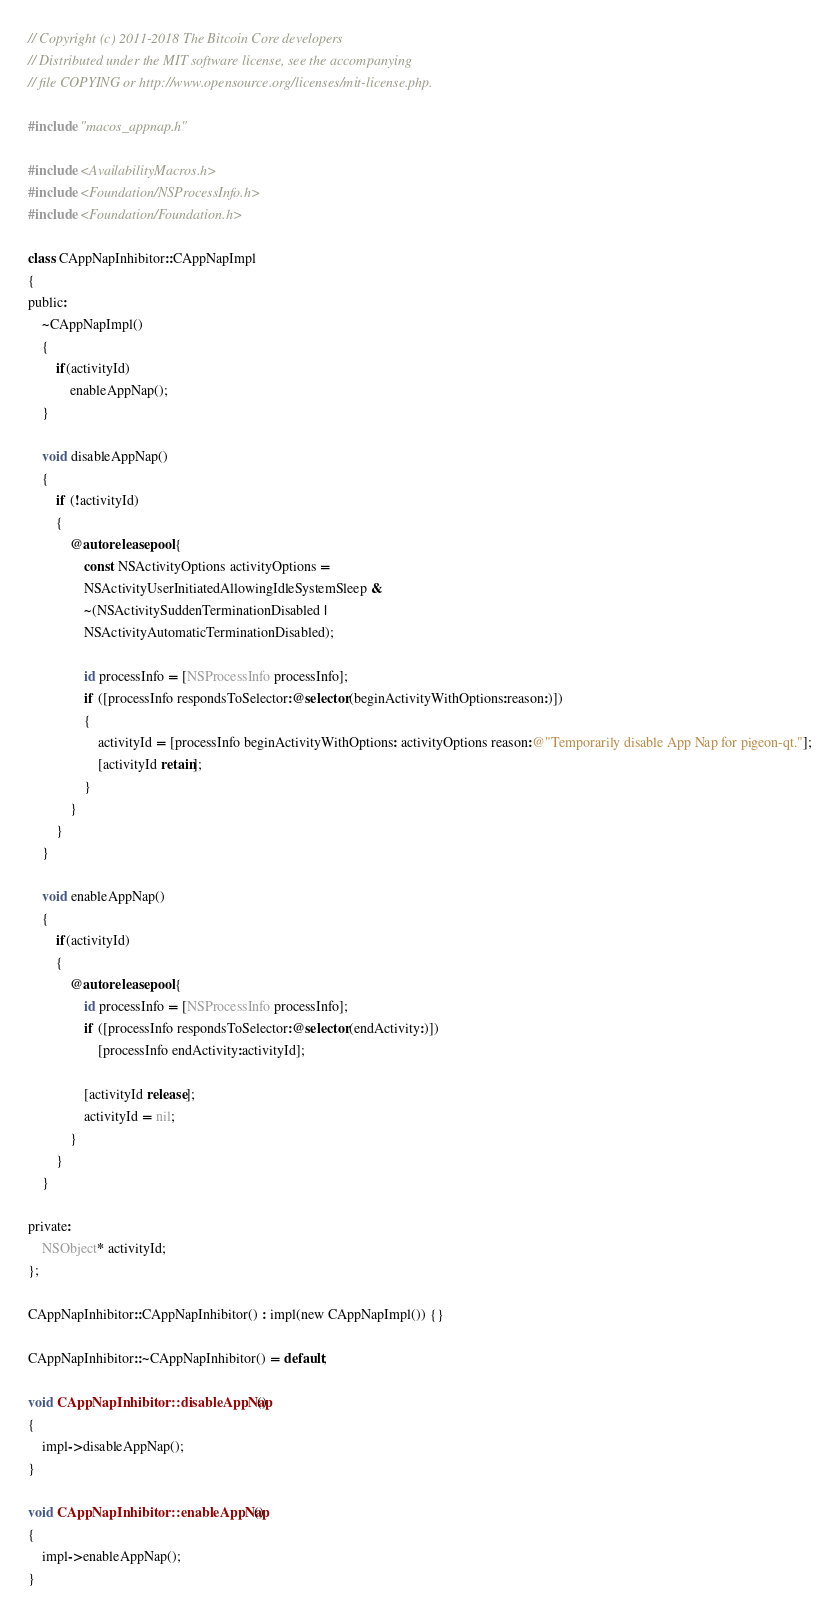<code> <loc_0><loc_0><loc_500><loc_500><_ObjectiveC_>// Copyright (c) 2011-2018 The Bitcoin Core developers
// Distributed under the MIT software license, see the accompanying
// file COPYING or http://www.opensource.org/licenses/mit-license.php.

#include "macos_appnap.h"

#include <AvailabilityMacros.h>
#include <Foundation/NSProcessInfo.h>
#include <Foundation/Foundation.h>

class CAppNapInhibitor::CAppNapImpl
{
public:
    ~CAppNapImpl()
    {
        if(activityId)
            enableAppNap();
    }

    void disableAppNap()
    {
        if (!activityId)
        {
            @autoreleasepool {
                const NSActivityOptions activityOptions =
                NSActivityUserInitiatedAllowingIdleSystemSleep &
                ~(NSActivitySuddenTerminationDisabled |
                NSActivityAutomaticTerminationDisabled);

                id processInfo = [NSProcessInfo processInfo];
                if ([processInfo respondsToSelector:@selector(beginActivityWithOptions:reason:)])
                {
                    activityId = [processInfo beginActivityWithOptions: activityOptions reason:@"Temporarily disable App Nap for pigeon-qt."];
                    [activityId retain];
                }
            }
        }
    }

    void enableAppNap()
    {
        if(activityId)
        {
            @autoreleasepool {
                id processInfo = [NSProcessInfo processInfo];
                if ([processInfo respondsToSelector:@selector(endActivity:)])
                    [processInfo endActivity:activityId];

                [activityId release];
                activityId = nil;
            }
        }
    }

private:
    NSObject* activityId;
};

CAppNapInhibitor::CAppNapInhibitor() : impl(new CAppNapImpl()) {}

CAppNapInhibitor::~CAppNapInhibitor() = default;

void CAppNapInhibitor::disableAppNap()
{
    impl->disableAppNap();
}

void CAppNapInhibitor::enableAppNap()
{
    impl->enableAppNap();
}
</code> 